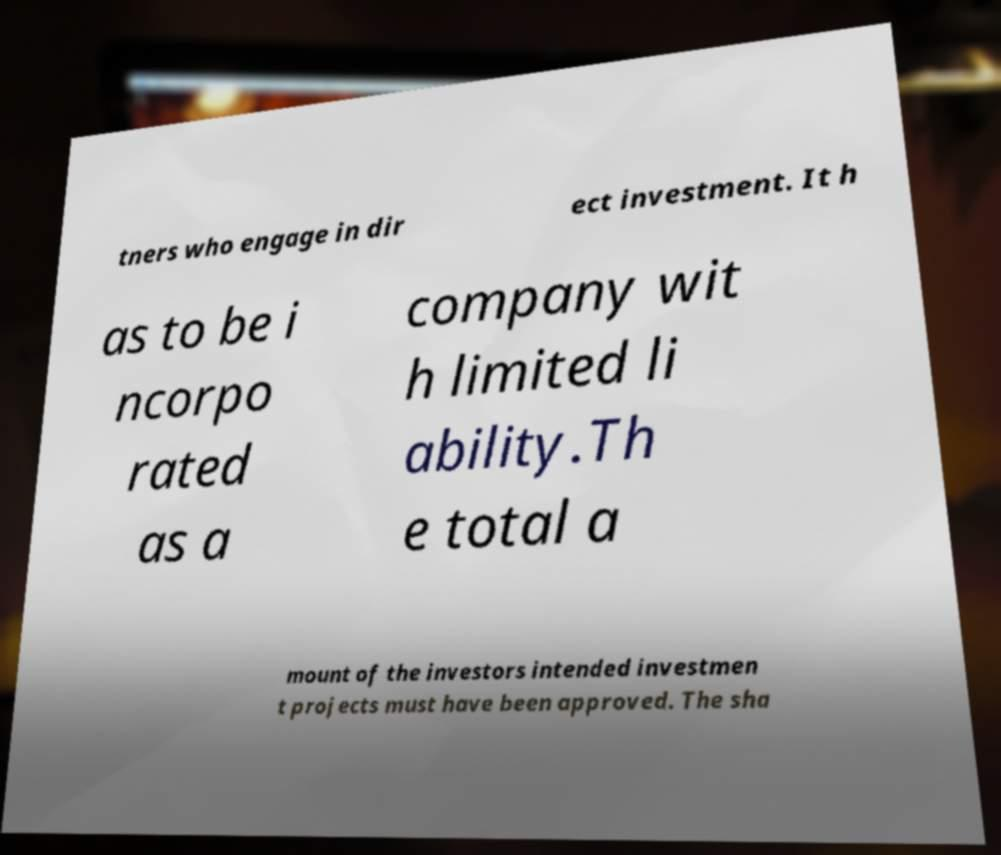Could you extract and type out the text from this image? tners who engage in dir ect investment. It h as to be i ncorpo rated as a company wit h limited li ability.Th e total a mount of the investors intended investmen t projects must have been approved. The sha 